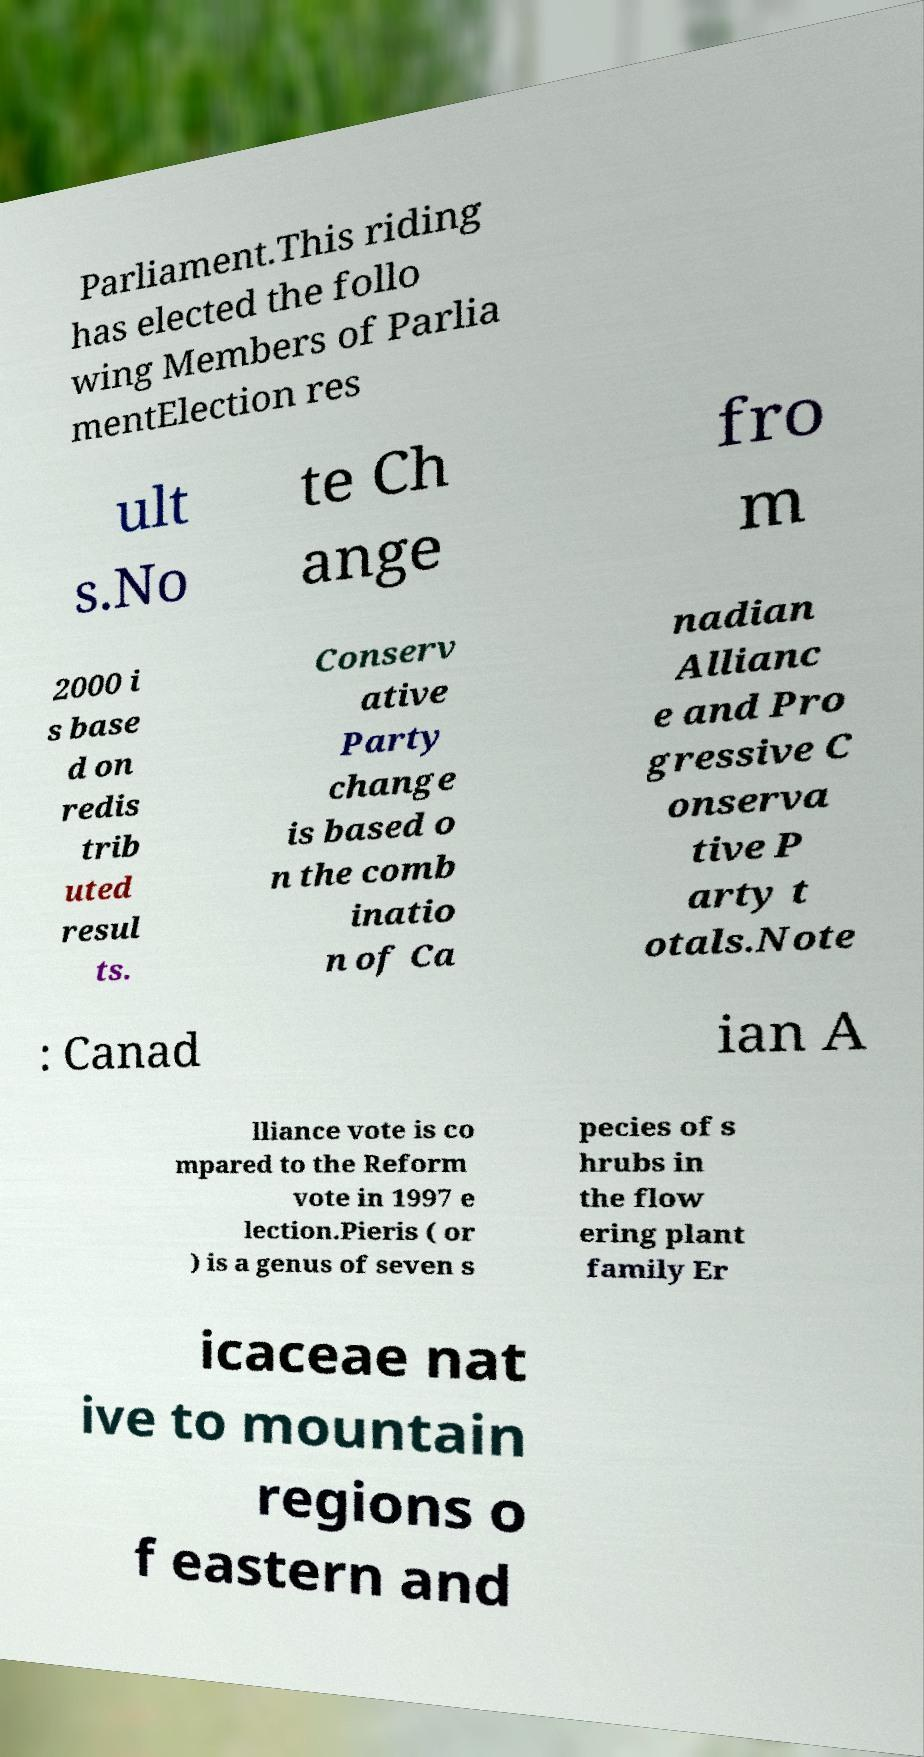Can you accurately transcribe the text from the provided image for me? Parliament.This riding has elected the follo wing Members of Parlia mentElection res ult s.No te Ch ange fro m 2000 i s base d on redis trib uted resul ts. Conserv ative Party change is based o n the comb inatio n of Ca nadian Allianc e and Pro gressive C onserva tive P arty t otals.Note : Canad ian A lliance vote is co mpared to the Reform vote in 1997 e lection.Pieris ( or ) is a genus of seven s pecies of s hrubs in the flow ering plant family Er icaceae nat ive to mountain regions o f eastern and 